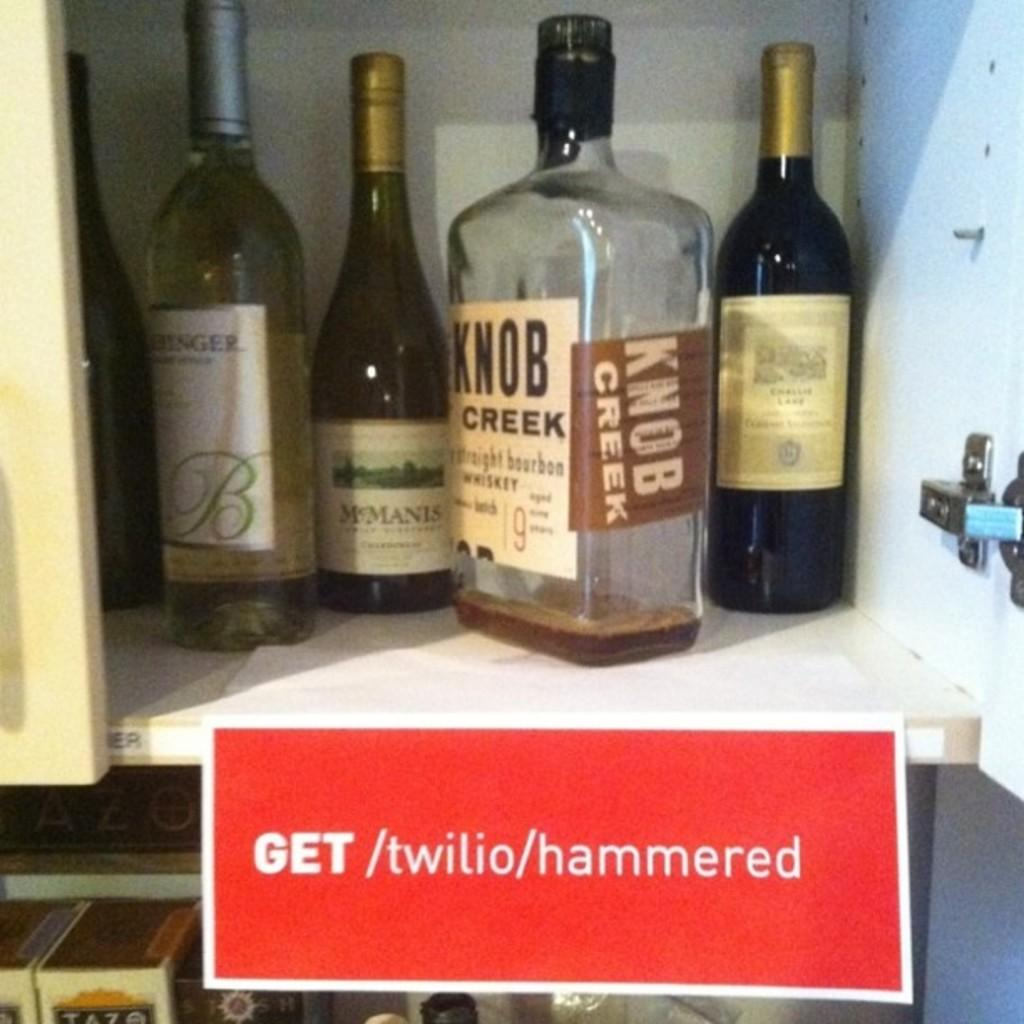How many bottles can be seen in the image? There are five bottles in the image. Where are the bottles located? The bottles are placed in a cupboard. Is there any additional information about the cupboard in the image? Yes, there is a name plate pasted under the cupboard. Can you hear the snails crawling on the name plate in the image? There are no snails present in the image, so it is not possible to hear them crawling on the name plate. 